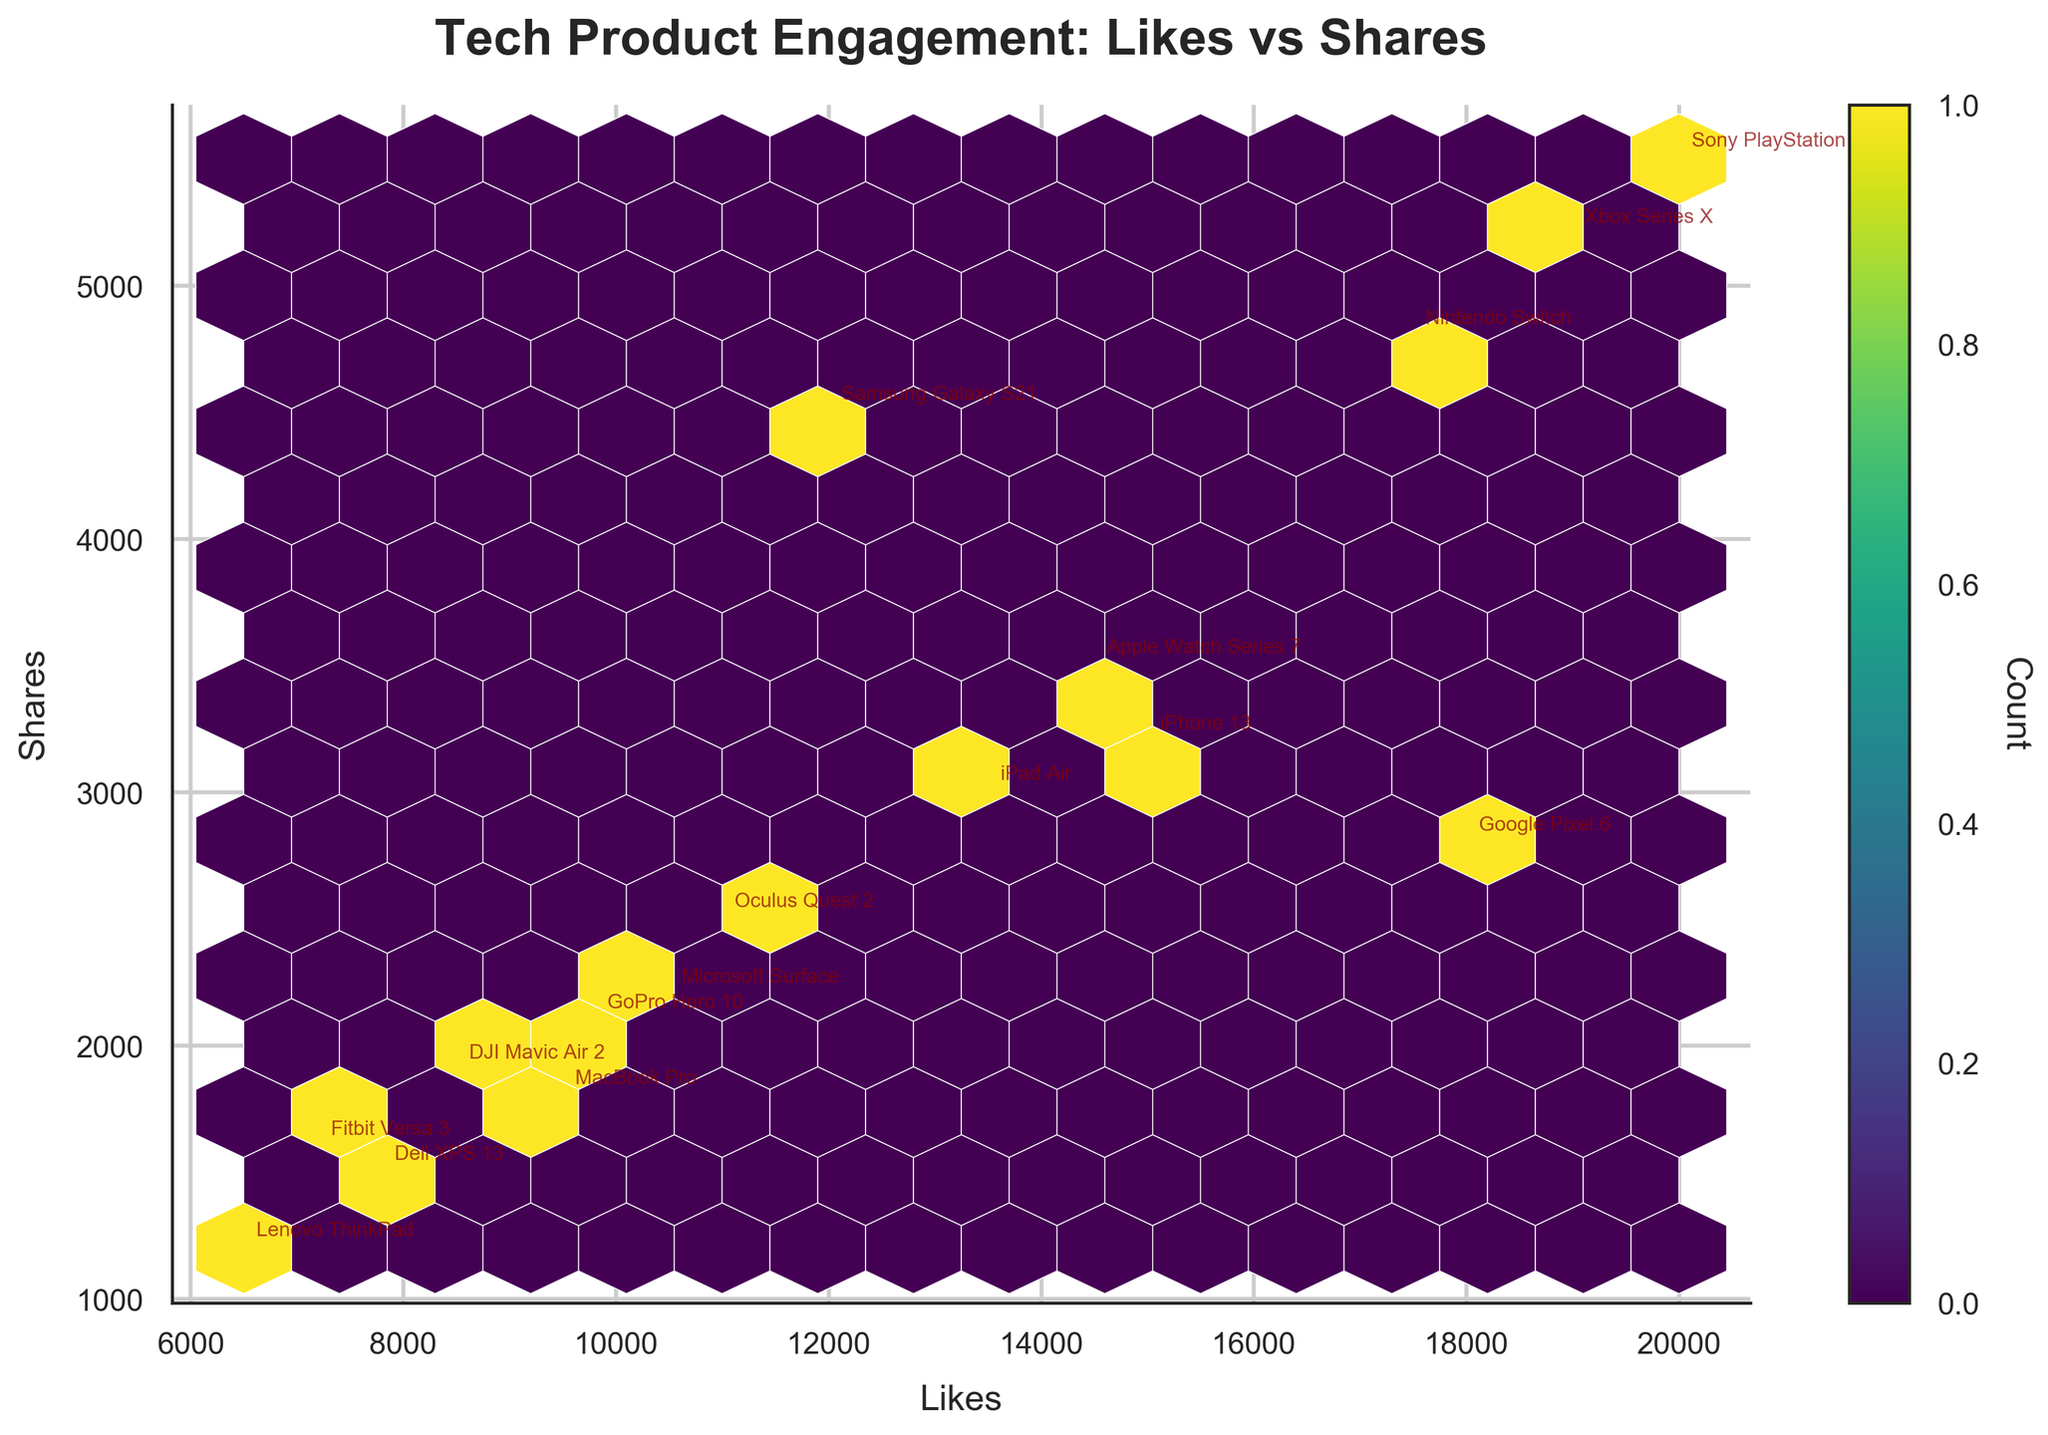What is the title of the hexbin plot? The title can be easily identified at the top of the hexbin plot. It is usually a short descriptive phrase indicating what the plot is about.
Answer: Tech Product Engagement: Likes vs Shares What is the relationship observed between likes and shares for most tech products? By looking at the hexbin plot, you can observe that most hexagons with higher counts are clustered together. This shows a positive relationship between likes and shares for tech products.
Answer: Positive relationship Which product has the highest number of likes and shares combined? To determine this, locate the product with the highest coordinates on the plot along both the likes and shares axes. Add the likes and shares for each product to identify the highest combined value.
Answer: Sony PlayStation 5 How many distinct points are there in the hexbin plot? Each product is marked as an individual point, identified by its name. Count the number of distinct annotated products in the plot.
Answer: 16 Between LinkedIn and Facebook platforms, which has more engagement (sum of likes and shares) for the listed tech products? Sum the likes and shares for all products listed on LinkedIn and Facebook. Compare the totals to determine which platform has more combined engagements.
Answer: Facebook Which product has substantially higher shares relative to its likes? Locate the points where the y-value (shares) is significantly higher relative to the x-value (likes). Choose the point that stands out the most in this aspect.
Answer: Samsung Galaxy S21 (Twitter) What does the color and size of the hexagons represent in the plot? This information can be inferred from the color bar. The color intensity and size of the hexagons represent the frequency of data points falling within that bin.
Answer: Count of data points Which platform shows more concentration of lower engagement metrics (likes and shares)? Look for regions on the hexbin plot with lighter colors and fewer hexagons. Identify the platform associated with those regions.
Answer: LinkedIn What is the overall trend in social media engagement for Instagram and Twitter compared to Facebook and LinkedIn? Compare the clusters for Instagram and Twitter to those for Facebook and LinkedIn. Note how the data points group along the axes to determine the overall trend.
Answer: Instagram and Twitter show higher engagement Which tech product has the least combined engagement (likes + shares)? Calculate the sum of likes and shares for each product. The product with the smallest total will have the least combined engagement.
Answer: Lenovo ThinkPad 